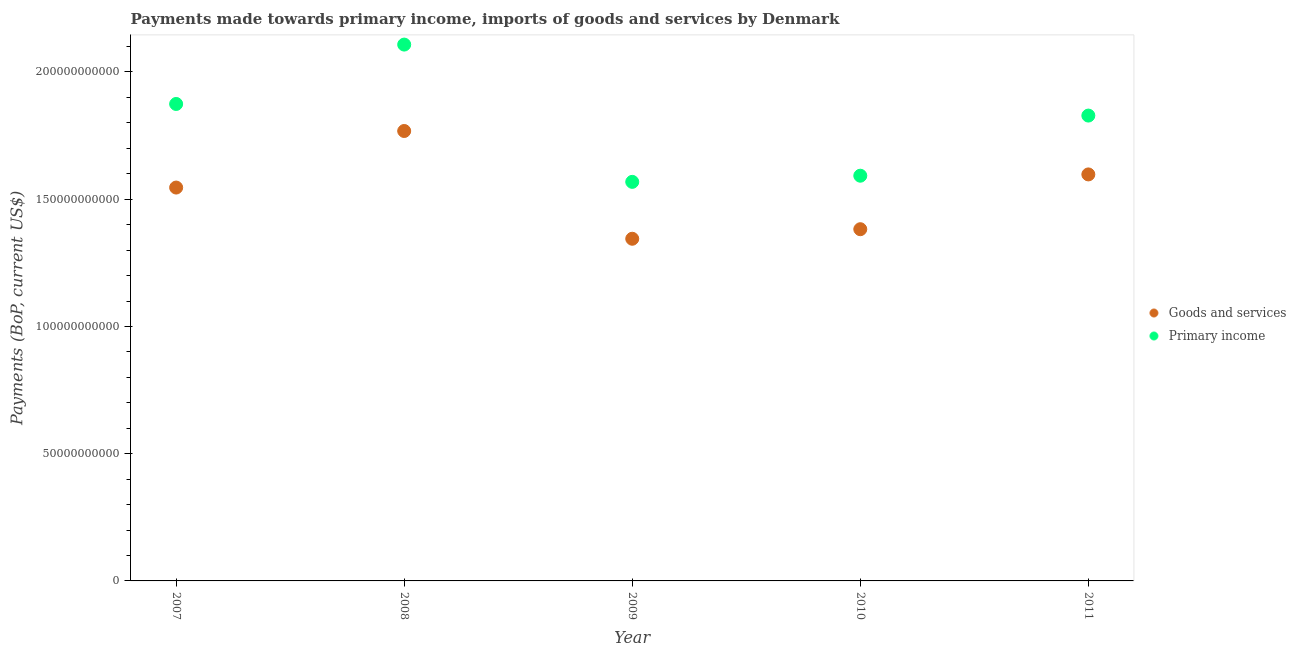What is the payments made towards primary income in 2007?
Your answer should be very brief. 1.87e+11. Across all years, what is the maximum payments made towards goods and services?
Your answer should be compact. 1.77e+11. Across all years, what is the minimum payments made towards goods and services?
Provide a short and direct response. 1.34e+11. In which year was the payments made towards primary income minimum?
Keep it short and to the point. 2009. What is the total payments made towards goods and services in the graph?
Offer a terse response. 7.64e+11. What is the difference between the payments made towards primary income in 2007 and that in 2010?
Your response must be concise. 2.82e+1. What is the difference between the payments made towards primary income in 2007 and the payments made towards goods and services in 2010?
Keep it short and to the point. 4.92e+1. What is the average payments made towards primary income per year?
Your response must be concise. 1.79e+11. In the year 2007, what is the difference between the payments made towards goods and services and payments made towards primary income?
Your response must be concise. -3.29e+1. In how many years, is the payments made towards goods and services greater than 70000000000 US$?
Your response must be concise. 5. What is the ratio of the payments made towards goods and services in 2009 to that in 2010?
Your answer should be very brief. 0.97. Is the difference between the payments made towards primary income in 2007 and 2010 greater than the difference between the payments made towards goods and services in 2007 and 2010?
Make the answer very short. Yes. What is the difference between the highest and the second highest payments made towards goods and services?
Your answer should be very brief. 1.71e+1. What is the difference between the highest and the lowest payments made towards primary income?
Give a very brief answer. 5.39e+1. Does the payments made towards goods and services monotonically increase over the years?
Provide a succinct answer. No. Is the payments made towards goods and services strictly less than the payments made towards primary income over the years?
Your answer should be compact. Yes. Are the values on the major ticks of Y-axis written in scientific E-notation?
Offer a terse response. No. How many legend labels are there?
Make the answer very short. 2. What is the title of the graph?
Ensure brevity in your answer.  Payments made towards primary income, imports of goods and services by Denmark. What is the label or title of the X-axis?
Your answer should be compact. Year. What is the label or title of the Y-axis?
Your answer should be very brief. Payments (BoP, current US$). What is the Payments (BoP, current US$) of Goods and services in 2007?
Make the answer very short. 1.55e+11. What is the Payments (BoP, current US$) of Primary income in 2007?
Provide a short and direct response. 1.87e+11. What is the Payments (BoP, current US$) of Goods and services in 2008?
Provide a short and direct response. 1.77e+11. What is the Payments (BoP, current US$) of Primary income in 2008?
Provide a succinct answer. 2.11e+11. What is the Payments (BoP, current US$) of Goods and services in 2009?
Your response must be concise. 1.34e+11. What is the Payments (BoP, current US$) in Primary income in 2009?
Provide a succinct answer. 1.57e+11. What is the Payments (BoP, current US$) of Goods and services in 2010?
Your answer should be compact. 1.38e+11. What is the Payments (BoP, current US$) in Primary income in 2010?
Offer a terse response. 1.59e+11. What is the Payments (BoP, current US$) in Goods and services in 2011?
Your answer should be very brief. 1.60e+11. What is the Payments (BoP, current US$) of Primary income in 2011?
Provide a succinct answer. 1.83e+11. Across all years, what is the maximum Payments (BoP, current US$) of Goods and services?
Give a very brief answer. 1.77e+11. Across all years, what is the maximum Payments (BoP, current US$) of Primary income?
Offer a very short reply. 2.11e+11. Across all years, what is the minimum Payments (BoP, current US$) of Goods and services?
Offer a terse response. 1.34e+11. Across all years, what is the minimum Payments (BoP, current US$) in Primary income?
Keep it short and to the point. 1.57e+11. What is the total Payments (BoP, current US$) of Goods and services in the graph?
Keep it short and to the point. 7.64e+11. What is the total Payments (BoP, current US$) of Primary income in the graph?
Your response must be concise. 8.97e+11. What is the difference between the Payments (BoP, current US$) of Goods and services in 2007 and that in 2008?
Your answer should be compact. -2.22e+1. What is the difference between the Payments (BoP, current US$) in Primary income in 2007 and that in 2008?
Ensure brevity in your answer.  -2.33e+1. What is the difference between the Payments (BoP, current US$) of Goods and services in 2007 and that in 2009?
Give a very brief answer. 2.01e+1. What is the difference between the Payments (BoP, current US$) in Primary income in 2007 and that in 2009?
Keep it short and to the point. 3.06e+1. What is the difference between the Payments (BoP, current US$) of Goods and services in 2007 and that in 2010?
Your answer should be compact. 1.64e+1. What is the difference between the Payments (BoP, current US$) in Primary income in 2007 and that in 2010?
Keep it short and to the point. 2.82e+1. What is the difference between the Payments (BoP, current US$) in Goods and services in 2007 and that in 2011?
Ensure brevity in your answer.  -5.16e+09. What is the difference between the Payments (BoP, current US$) of Primary income in 2007 and that in 2011?
Provide a succinct answer. 4.56e+09. What is the difference between the Payments (BoP, current US$) in Goods and services in 2008 and that in 2009?
Your answer should be compact. 4.23e+1. What is the difference between the Payments (BoP, current US$) of Primary income in 2008 and that in 2009?
Your answer should be compact. 5.39e+1. What is the difference between the Payments (BoP, current US$) of Goods and services in 2008 and that in 2010?
Provide a short and direct response. 3.86e+1. What is the difference between the Payments (BoP, current US$) of Primary income in 2008 and that in 2010?
Offer a terse response. 5.15e+1. What is the difference between the Payments (BoP, current US$) in Goods and services in 2008 and that in 2011?
Provide a short and direct response. 1.71e+1. What is the difference between the Payments (BoP, current US$) of Primary income in 2008 and that in 2011?
Your answer should be compact. 2.79e+1. What is the difference between the Payments (BoP, current US$) in Goods and services in 2009 and that in 2010?
Provide a short and direct response. -3.75e+09. What is the difference between the Payments (BoP, current US$) in Primary income in 2009 and that in 2010?
Give a very brief answer. -2.42e+09. What is the difference between the Payments (BoP, current US$) in Goods and services in 2009 and that in 2011?
Your response must be concise. -2.53e+1. What is the difference between the Payments (BoP, current US$) in Primary income in 2009 and that in 2011?
Offer a terse response. -2.60e+1. What is the difference between the Payments (BoP, current US$) of Goods and services in 2010 and that in 2011?
Provide a succinct answer. -2.15e+1. What is the difference between the Payments (BoP, current US$) of Primary income in 2010 and that in 2011?
Your answer should be compact. -2.36e+1. What is the difference between the Payments (BoP, current US$) of Goods and services in 2007 and the Payments (BoP, current US$) of Primary income in 2008?
Keep it short and to the point. -5.62e+1. What is the difference between the Payments (BoP, current US$) in Goods and services in 2007 and the Payments (BoP, current US$) in Primary income in 2009?
Your answer should be compact. -2.24e+09. What is the difference between the Payments (BoP, current US$) in Goods and services in 2007 and the Payments (BoP, current US$) in Primary income in 2010?
Make the answer very short. -4.65e+09. What is the difference between the Payments (BoP, current US$) of Goods and services in 2007 and the Payments (BoP, current US$) of Primary income in 2011?
Keep it short and to the point. -2.83e+1. What is the difference between the Payments (BoP, current US$) in Goods and services in 2008 and the Payments (BoP, current US$) in Primary income in 2009?
Offer a terse response. 2.00e+1. What is the difference between the Payments (BoP, current US$) of Goods and services in 2008 and the Payments (BoP, current US$) of Primary income in 2010?
Provide a succinct answer. 1.76e+1. What is the difference between the Payments (BoP, current US$) of Goods and services in 2008 and the Payments (BoP, current US$) of Primary income in 2011?
Provide a succinct answer. -6.06e+09. What is the difference between the Payments (BoP, current US$) of Goods and services in 2009 and the Payments (BoP, current US$) of Primary income in 2010?
Keep it short and to the point. -2.48e+1. What is the difference between the Payments (BoP, current US$) in Goods and services in 2009 and the Payments (BoP, current US$) in Primary income in 2011?
Your answer should be very brief. -4.84e+1. What is the difference between the Payments (BoP, current US$) of Goods and services in 2010 and the Payments (BoP, current US$) of Primary income in 2011?
Keep it short and to the point. -4.47e+1. What is the average Payments (BoP, current US$) of Goods and services per year?
Provide a succinct answer. 1.53e+11. What is the average Payments (BoP, current US$) of Primary income per year?
Offer a very short reply. 1.79e+11. In the year 2007, what is the difference between the Payments (BoP, current US$) of Goods and services and Payments (BoP, current US$) of Primary income?
Offer a very short reply. -3.29e+1. In the year 2008, what is the difference between the Payments (BoP, current US$) in Goods and services and Payments (BoP, current US$) in Primary income?
Offer a very short reply. -3.40e+1. In the year 2009, what is the difference between the Payments (BoP, current US$) of Goods and services and Payments (BoP, current US$) of Primary income?
Offer a terse response. -2.24e+1. In the year 2010, what is the difference between the Payments (BoP, current US$) in Goods and services and Payments (BoP, current US$) in Primary income?
Provide a succinct answer. -2.10e+1. In the year 2011, what is the difference between the Payments (BoP, current US$) of Goods and services and Payments (BoP, current US$) of Primary income?
Make the answer very short. -2.31e+1. What is the ratio of the Payments (BoP, current US$) in Goods and services in 2007 to that in 2008?
Make the answer very short. 0.87. What is the ratio of the Payments (BoP, current US$) of Primary income in 2007 to that in 2008?
Keep it short and to the point. 0.89. What is the ratio of the Payments (BoP, current US$) in Goods and services in 2007 to that in 2009?
Offer a very short reply. 1.15. What is the ratio of the Payments (BoP, current US$) in Primary income in 2007 to that in 2009?
Give a very brief answer. 1.2. What is the ratio of the Payments (BoP, current US$) of Goods and services in 2007 to that in 2010?
Offer a terse response. 1.12. What is the ratio of the Payments (BoP, current US$) of Primary income in 2007 to that in 2010?
Offer a very short reply. 1.18. What is the ratio of the Payments (BoP, current US$) of Goods and services in 2008 to that in 2009?
Your answer should be very brief. 1.31. What is the ratio of the Payments (BoP, current US$) in Primary income in 2008 to that in 2009?
Offer a terse response. 1.34. What is the ratio of the Payments (BoP, current US$) in Goods and services in 2008 to that in 2010?
Your answer should be very brief. 1.28. What is the ratio of the Payments (BoP, current US$) of Primary income in 2008 to that in 2010?
Ensure brevity in your answer.  1.32. What is the ratio of the Payments (BoP, current US$) of Goods and services in 2008 to that in 2011?
Make the answer very short. 1.11. What is the ratio of the Payments (BoP, current US$) of Primary income in 2008 to that in 2011?
Your answer should be very brief. 1.15. What is the ratio of the Payments (BoP, current US$) in Goods and services in 2009 to that in 2010?
Keep it short and to the point. 0.97. What is the ratio of the Payments (BoP, current US$) in Goods and services in 2009 to that in 2011?
Your response must be concise. 0.84. What is the ratio of the Payments (BoP, current US$) of Primary income in 2009 to that in 2011?
Ensure brevity in your answer.  0.86. What is the ratio of the Payments (BoP, current US$) of Goods and services in 2010 to that in 2011?
Ensure brevity in your answer.  0.87. What is the ratio of the Payments (BoP, current US$) of Primary income in 2010 to that in 2011?
Offer a terse response. 0.87. What is the difference between the highest and the second highest Payments (BoP, current US$) of Goods and services?
Your answer should be compact. 1.71e+1. What is the difference between the highest and the second highest Payments (BoP, current US$) of Primary income?
Offer a very short reply. 2.33e+1. What is the difference between the highest and the lowest Payments (BoP, current US$) of Goods and services?
Offer a very short reply. 4.23e+1. What is the difference between the highest and the lowest Payments (BoP, current US$) in Primary income?
Keep it short and to the point. 5.39e+1. 